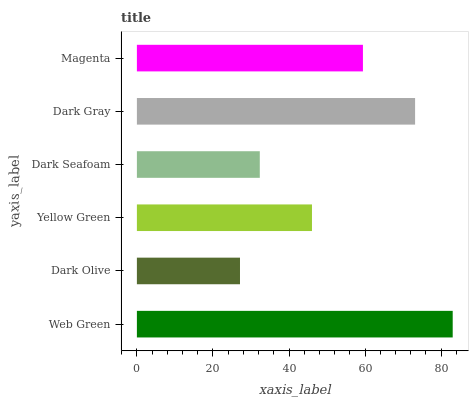Is Dark Olive the minimum?
Answer yes or no. Yes. Is Web Green the maximum?
Answer yes or no. Yes. Is Yellow Green the minimum?
Answer yes or no. No. Is Yellow Green the maximum?
Answer yes or no. No. Is Yellow Green greater than Dark Olive?
Answer yes or no. Yes. Is Dark Olive less than Yellow Green?
Answer yes or no. Yes. Is Dark Olive greater than Yellow Green?
Answer yes or no. No. Is Yellow Green less than Dark Olive?
Answer yes or no. No. Is Magenta the high median?
Answer yes or no. Yes. Is Yellow Green the low median?
Answer yes or no. Yes. Is Yellow Green the high median?
Answer yes or no. No. Is Dark Seafoam the low median?
Answer yes or no. No. 